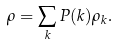Convert formula to latex. <formula><loc_0><loc_0><loc_500><loc_500>\rho = \sum _ { k } P ( k ) \rho _ { k } .</formula> 